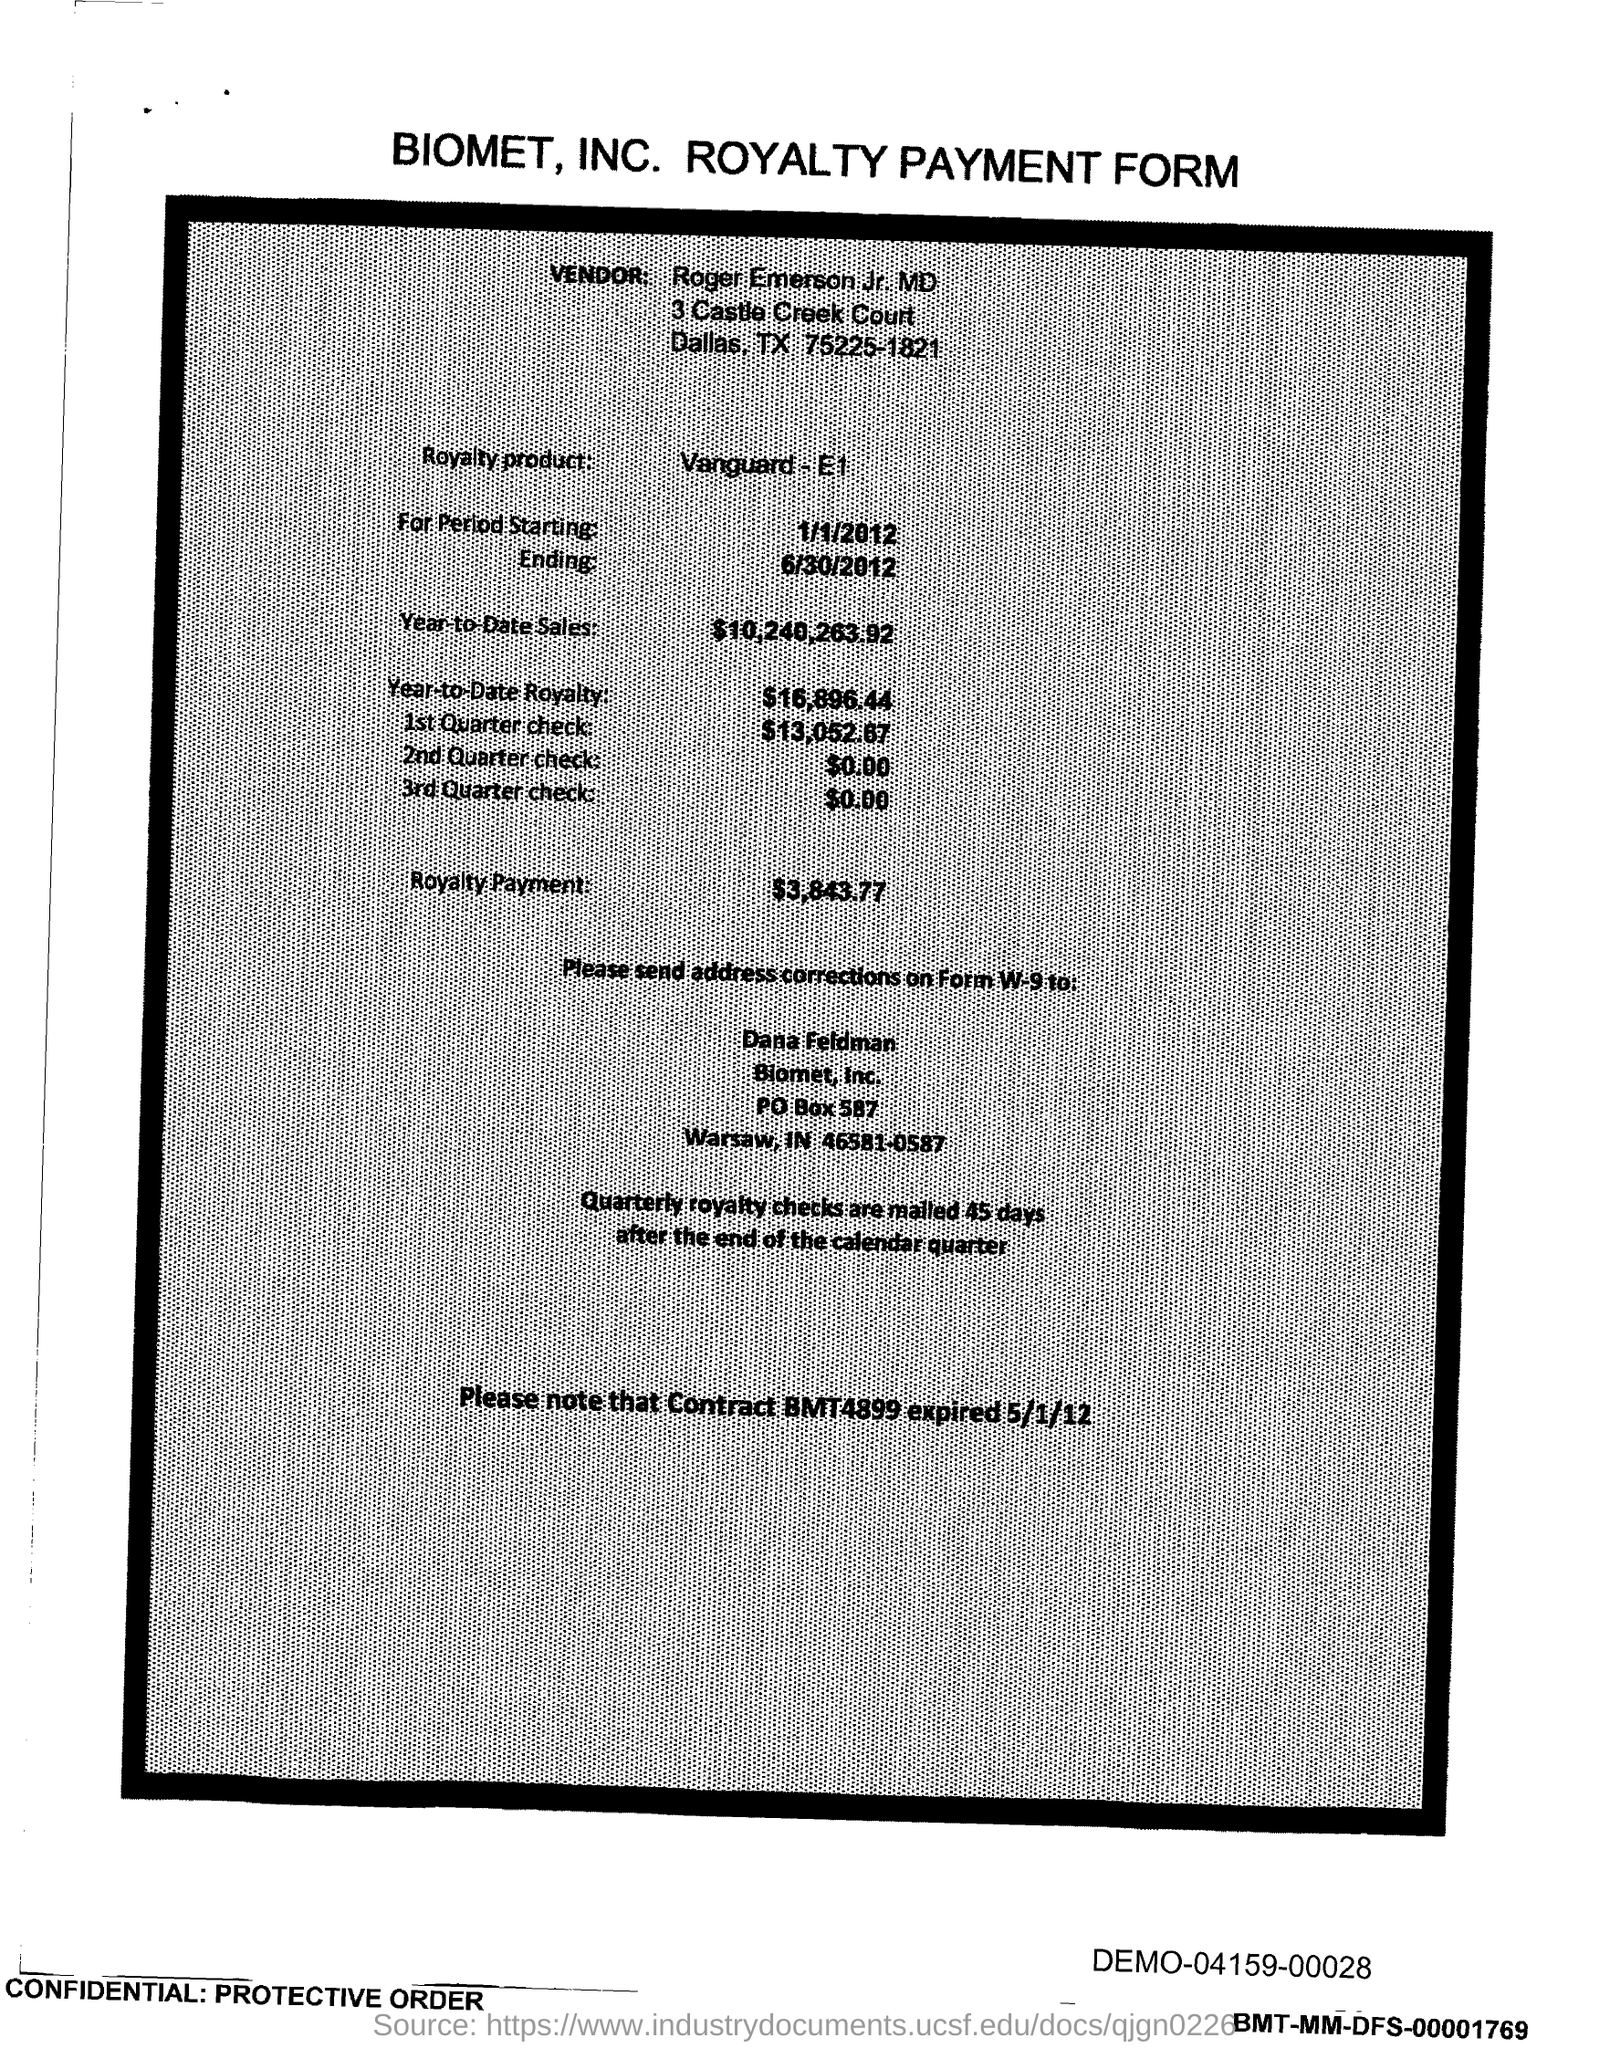What is the vendor name mentioned in the form?
Make the answer very short. Roger Emerson Jr. MD. What is the royalty product given in the form?
Your answer should be compact. Vanguard - E1. What is the start date of the royalty period?
Your response must be concise. 1/1/2012. What is the Year-to-Date Sales of the royalty product?
Ensure brevity in your answer.  $10,240,263.92. What is the Year-to-Date royalty of the product?
Keep it short and to the point. $16,896.44. What is the amount of 1st quarter check mentioned in the form?
Provide a short and direct response. $13,052.67. What is the amount of 2nd Quarter check mentioned in the form?
Give a very brief answer. $0.00. What is the royalty payment of the product mentioned in the form?
Provide a short and direct response. $3,843.77. What is the end date of the royalty period?
Offer a terse response. 6/30/2012. 